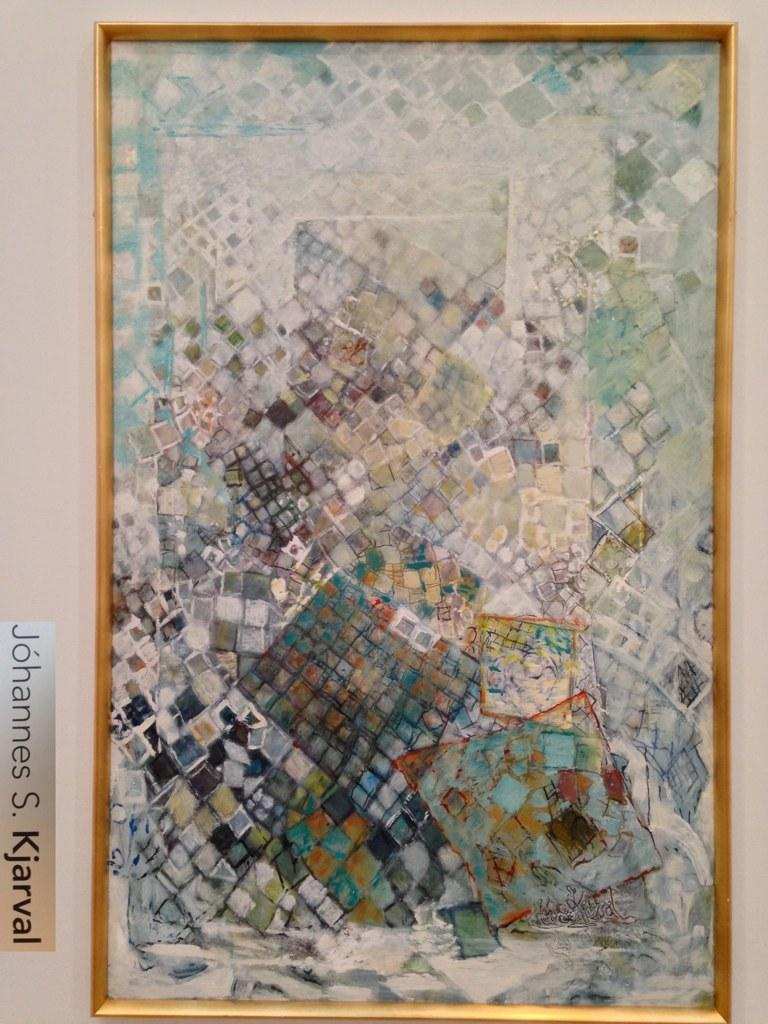<image>
Share a concise interpretation of the image provided. A painting by Johannes S Kjaraval hangs on a white wall 